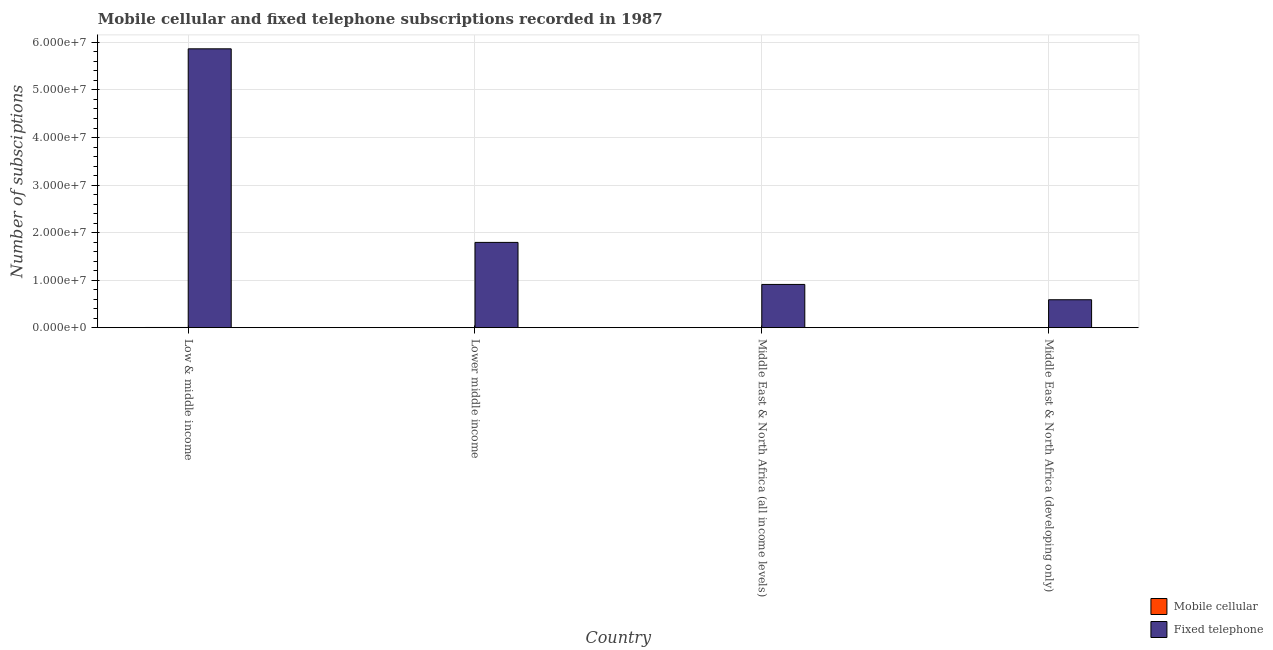How many different coloured bars are there?
Keep it short and to the point. 2. How many bars are there on the 3rd tick from the right?
Offer a terse response. 2. What is the label of the 3rd group of bars from the left?
Give a very brief answer. Middle East & North Africa (all income levels). What is the number of fixed telephone subscriptions in Low & middle income?
Give a very brief answer. 5.87e+07. Across all countries, what is the maximum number of fixed telephone subscriptions?
Provide a short and direct response. 5.87e+07. Across all countries, what is the minimum number of fixed telephone subscriptions?
Your response must be concise. 5.87e+06. In which country was the number of mobile cellular subscriptions maximum?
Your answer should be very brief. Low & middle income. In which country was the number of fixed telephone subscriptions minimum?
Provide a short and direct response. Middle East & North Africa (developing only). What is the total number of fixed telephone subscriptions in the graph?
Your answer should be compact. 9.16e+07. What is the difference between the number of fixed telephone subscriptions in Low & middle income and that in Middle East & North Africa (all income levels)?
Offer a terse response. 4.96e+07. What is the difference between the number of mobile cellular subscriptions in Lower middle income and the number of fixed telephone subscriptions in Middle East & North Africa (all income levels)?
Your answer should be compact. -9.08e+06. What is the average number of fixed telephone subscriptions per country?
Make the answer very short. 2.29e+07. What is the difference between the number of mobile cellular subscriptions and number of fixed telephone subscriptions in Lower middle income?
Give a very brief answer. -1.79e+07. In how many countries, is the number of mobile cellular subscriptions greater than 28000000 ?
Make the answer very short. 0. What is the ratio of the number of fixed telephone subscriptions in Low & middle income to that in Lower middle income?
Give a very brief answer. 3.27. Is the difference between the number of fixed telephone subscriptions in Low & middle income and Middle East & North Africa (developing only) greater than the difference between the number of mobile cellular subscriptions in Low & middle income and Middle East & North Africa (developing only)?
Give a very brief answer. Yes. What is the difference between the highest and the second highest number of mobile cellular subscriptions?
Provide a short and direct response. 4533. What is the difference between the highest and the lowest number of mobile cellular subscriptions?
Offer a terse response. 3.54e+04. What does the 2nd bar from the left in Lower middle income represents?
Provide a short and direct response. Fixed telephone. What does the 1st bar from the right in Lower middle income represents?
Give a very brief answer. Fixed telephone. How many bars are there?
Ensure brevity in your answer.  8. Are all the bars in the graph horizontal?
Your response must be concise. No. How many countries are there in the graph?
Ensure brevity in your answer.  4. Are the values on the major ticks of Y-axis written in scientific E-notation?
Your answer should be very brief. Yes. Does the graph contain any zero values?
Offer a very short reply. No. How many legend labels are there?
Offer a very short reply. 2. What is the title of the graph?
Make the answer very short. Mobile cellular and fixed telephone subscriptions recorded in 1987. What is the label or title of the Y-axis?
Your answer should be compact. Number of subsciptions. What is the Number of subsciptions of Mobile cellular in Low & middle income?
Your response must be concise. 3.83e+04. What is the Number of subsciptions in Fixed telephone in Low & middle income?
Make the answer very short. 5.87e+07. What is the Number of subsciptions in Mobile cellular in Lower middle income?
Give a very brief answer. 9008. What is the Number of subsciptions in Fixed telephone in Lower middle income?
Provide a short and direct response. 1.79e+07. What is the Number of subsciptions in Mobile cellular in Middle East & North Africa (all income levels)?
Your response must be concise. 3.38e+04. What is the Number of subsciptions in Fixed telephone in Middle East & North Africa (all income levels)?
Give a very brief answer. 9.09e+06. What is the Number of subsciptions in Mobile cellular in Middle East & North Africa (developing only)?
Your answer should be compact. 2911. What is the Number of subsciptions of Fixed telephone in Middle East & North Africa (developing only)?
Keep it short and to the point. 5.87e+06. Across all countries, what is the maximum Number of subsciptions of Mobile cellular?
Offer a terse response. 3.83e+04. Across all countries, what is the maximum Number of subsciptions in Fixed telephone?
Your answer should be compact. 5.87e+07. Across all countries, what is the minimum Number of subsciptions in Mobile cellular?
Your response must be concise. 2911. Across all countries, what is the minimum Number of subsciptions in Fixed telephone?
Provide a succinct answer. 5.87e+06. What is the total Number of subsciptions of Mobile cellular in the graph?
Give a very brief answer. 8.40e+04. What is the total Number of subsciptions in Fixed telephone in the graph?
Make the answer very short. 9.16e+07. What is the difference between the Number of subsciptions in Mobile cellular in Low & middle income and that in Lower middle income?
Your answer should be very brief. 2.93e+04. What is the difference between the Number of subsciptions of Fixed telephone in Low & middle income and that in Lower middle income?
Your answer should be compact. 4.07e+07. What is the difference between the Number of subsciptions of Mobile cellular in Low & middle income and that in Middle East & North Africa (all income levels)?
Make the answer very short. 4533. What is the difference between the Number of subsciptions of Fixed telephone in Low & middle income and that in Middle East & North Africa (all income levels)?
Your answer should be very brief. 4.96e+07. What is the difference between the Number of subsciptions in Mobile cellular in Low & middle income and that in Middle East & North Africa (developing only)?
Provide a short and direct response. 3.54e+04. What is the difference between the Number of subsciptions in Fixed telephone in Low & middle income and that in Middle East & North Africa (developing only)?
Offer a very short reply. 5.28e+07. What is the difference between the Number of subsciptions in Mobile cellular in Lower middle income and that in Middle East & North Africa (all income levels)?
Offer a very short reply. -2.48e+04. What is the difference between the Number of subsciptions in Fixed telephone in Lower middle income and that in Middle East & North Africa (all income levels)?
Keep it short and to the point. 8.84e+06. What is the difference between the Number of subsciptions in Mobile cellular in Lower middle income and that in Middle East & North Africa (developing only)?
Offer a terse response. 6097. What is the difference between the Number of subsciptions of Fixed telephone in Lower middle income and that in Middle East & North Africa (developing only)?
Ensure brevity in your answer.  1.21e+07. What is the difference between the Number of subsciptions of Mobile cellular in Middle East & North Africa (all income levels) and that in Middle East & North Africa (developing only)?
Make the answer very short. 3.09e+04. What is the difference between the Number of subsciptions in Fixed telephone in Middle East & North Africa (all income levels) and that in Middle East & North Africa (developing only)?
Provide a succinct answer. 3.22e+06. What is the difference between the Number of subsciptions in Mobile cellular in Low & middle income and the Number of subsciptions in Fixed telephone in Lower middle income?
Offer a terse response. -1.79e+07. What is the difference between the Number of subsciptions in Mobile cellular in Low & middle income and the Number of subsciptions in Fixed telephone in Middle East & North Africa (all income levels)?
Your response must be concise. -9.06e+06. What is the difference between the Number of subsciptions of Mobile cellular in Low & middle income and the Number of subsciptions of Fixed telephone in Middle East & North Africa (developing only)?
Offer a very short reply. -5.84e+06. What is the difference between the Number of subsciptions in Mobile cellular in Lower middle income and the Number of subsciptions in Fixed telephone in Middle East & North Africa (all income levels)?
Your response must be concise. -9.08e+06. What is the difference between the Number of subsciptions in Mobile cellular in Lower middle income and the Number of subsciptions in Fixed telephone in Middle East & North Africa (developing only)?
Offer a terse response. -5.87e+06. What is the difference between the Number of subsciptions of Mobile cellular in Middle East & North Africa (all income levels) and the Number of subsciptions of Fixed telephone in Middle East & North Africa (developing only)?
Offer a terse response. -5.84e+06. What is the average Number of subsciptions of Mobile cellular per country?
Keep it short and to the point. 2.10e+04. What is the average Number of subsciptions in Fixed telephone per country?
Your answer should be very brief. 2.29e+07. What is the difference between the Number of subsciptions in Mobile cellular and Number of subsciptions in Fixed telephone in Low & middle income?
Your answer should be very brief. -5.86e+07. What is the difference between the Number of subsciptions in Mobile cellular and Number of subsciptions in Fixed telephone in Lower middle income?
Your answer should be compact. -1.79e+07. What is the difference between the Number of subsciptions in Mobile cellular and Number of subsciptions in Fixed telephone in Middle East & North Africa (all income levels)?
Your response must be concise. -9.06e+06. What is the difference between the Number of subsciptions in Mobile cellular and Number of subsciptions in Fixed telephone in Middle East & North Africa (developing only)?
Your answer should be very brief. -5.87e+06. What is the ratio of the Number of subsciptions of Mobile cellular in Low & middle income to that in Lower middle income?
Your answer should be very brief. 4.25. What is the ratio of the Number of subsciptions of Fixed telephone in Low & middle income to that in Lower middle income?
Provide a short and direct response. 3.27. What is the ratio of the Number of subsciptions in Mobile cellular in Low & middle income to that in Middle East & North Africa (all income levels)?
Give a very brief answer. 1.13. What is the ratio of the Number of subsciptions in Fixed telephone in Low & middle income to that in Middle East & North Africa (all income levels)?
Your answer should be very brief. 6.45. What is the ratio of the Number of subsciptions of Mobile cellular in Low & middle income to that in Middle East & North Africa (developing only)?
Your response must be concise. 13.17. What is the ratio of the Number of subsciptions of Fixed telephone in Low & middle income to that in Middle East & North Africa (developing only)?
Offer a very short reply. 9.99. What is the ratio of the Number of subsciptions in Mobile cellular in Lower middle income to that in Middle East & North Africa (all income levels)?
Give a very brief answer. 0.27. What is the ratio of the Number of subsciptions of Fixed telephone in Lower middle income to that in Middle East & North Africa (all income levels)?
Make the answer very short. 1.97. What is the ratio of the Number of subsciptions of Mobile cellular in Lower middle income to that in Middle East & North Africa (developing only)?
Make the answer very short. 3.09. What is the ratio of the Number of subsciptions of Fixed telephone in Lower middle income to that in Middle East & North Africa (developing only)?
Offer a very short reply. 3.05. What is the ratio of the Number of subsciptions in Mobile cellular in Middle East & North Africa (all income levels) to that in Middle East & North Africa (developing only)?
Offer a very short reply. 11.61. What is the ratio of the Number of subsciptions in Fixed telephone in Middle East & North Africa (all income levels) to that in Middle East & North Africa (developing only)?
Give a very brief answer. 1.55. What is the difference between the highest and the second highest Number of subsciptions of Mobile cellular?
Provide a succinct answer. 4533. What is the difference between the highest and the second highest Number of subsciptions in Fixed telephone?
Your response must be concise. 4.07e+07. What is the difference between the highest and the lowest Number of subsciptions in Mobile cellular?
Keep it short and to the point. 3.54e+04. What is the difference between the highest and the lowest Number of subsciptions of Fixed telephone?
Give a very brief answer. 5.28e+07. 